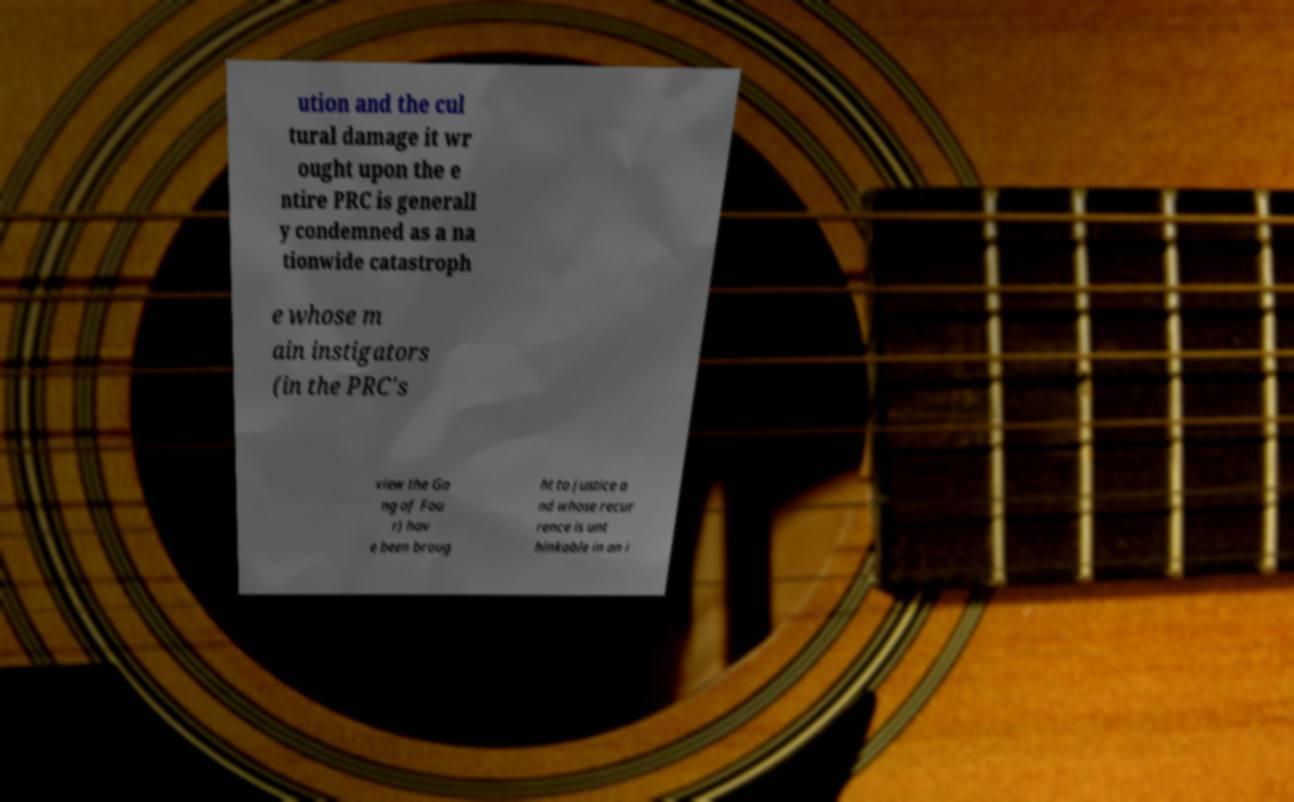I need the written content from this picture converted into text. Can you do that? ution and the cul tural damage it wr ought upon the e ntire PRC is generall y condemned as a na tionwide catastroph e whose m ain instigators (in the PRC's view the Ga ng of Fou r) hav e been broug ht to justice a nd whose recur rence is unt hinkable in an i 